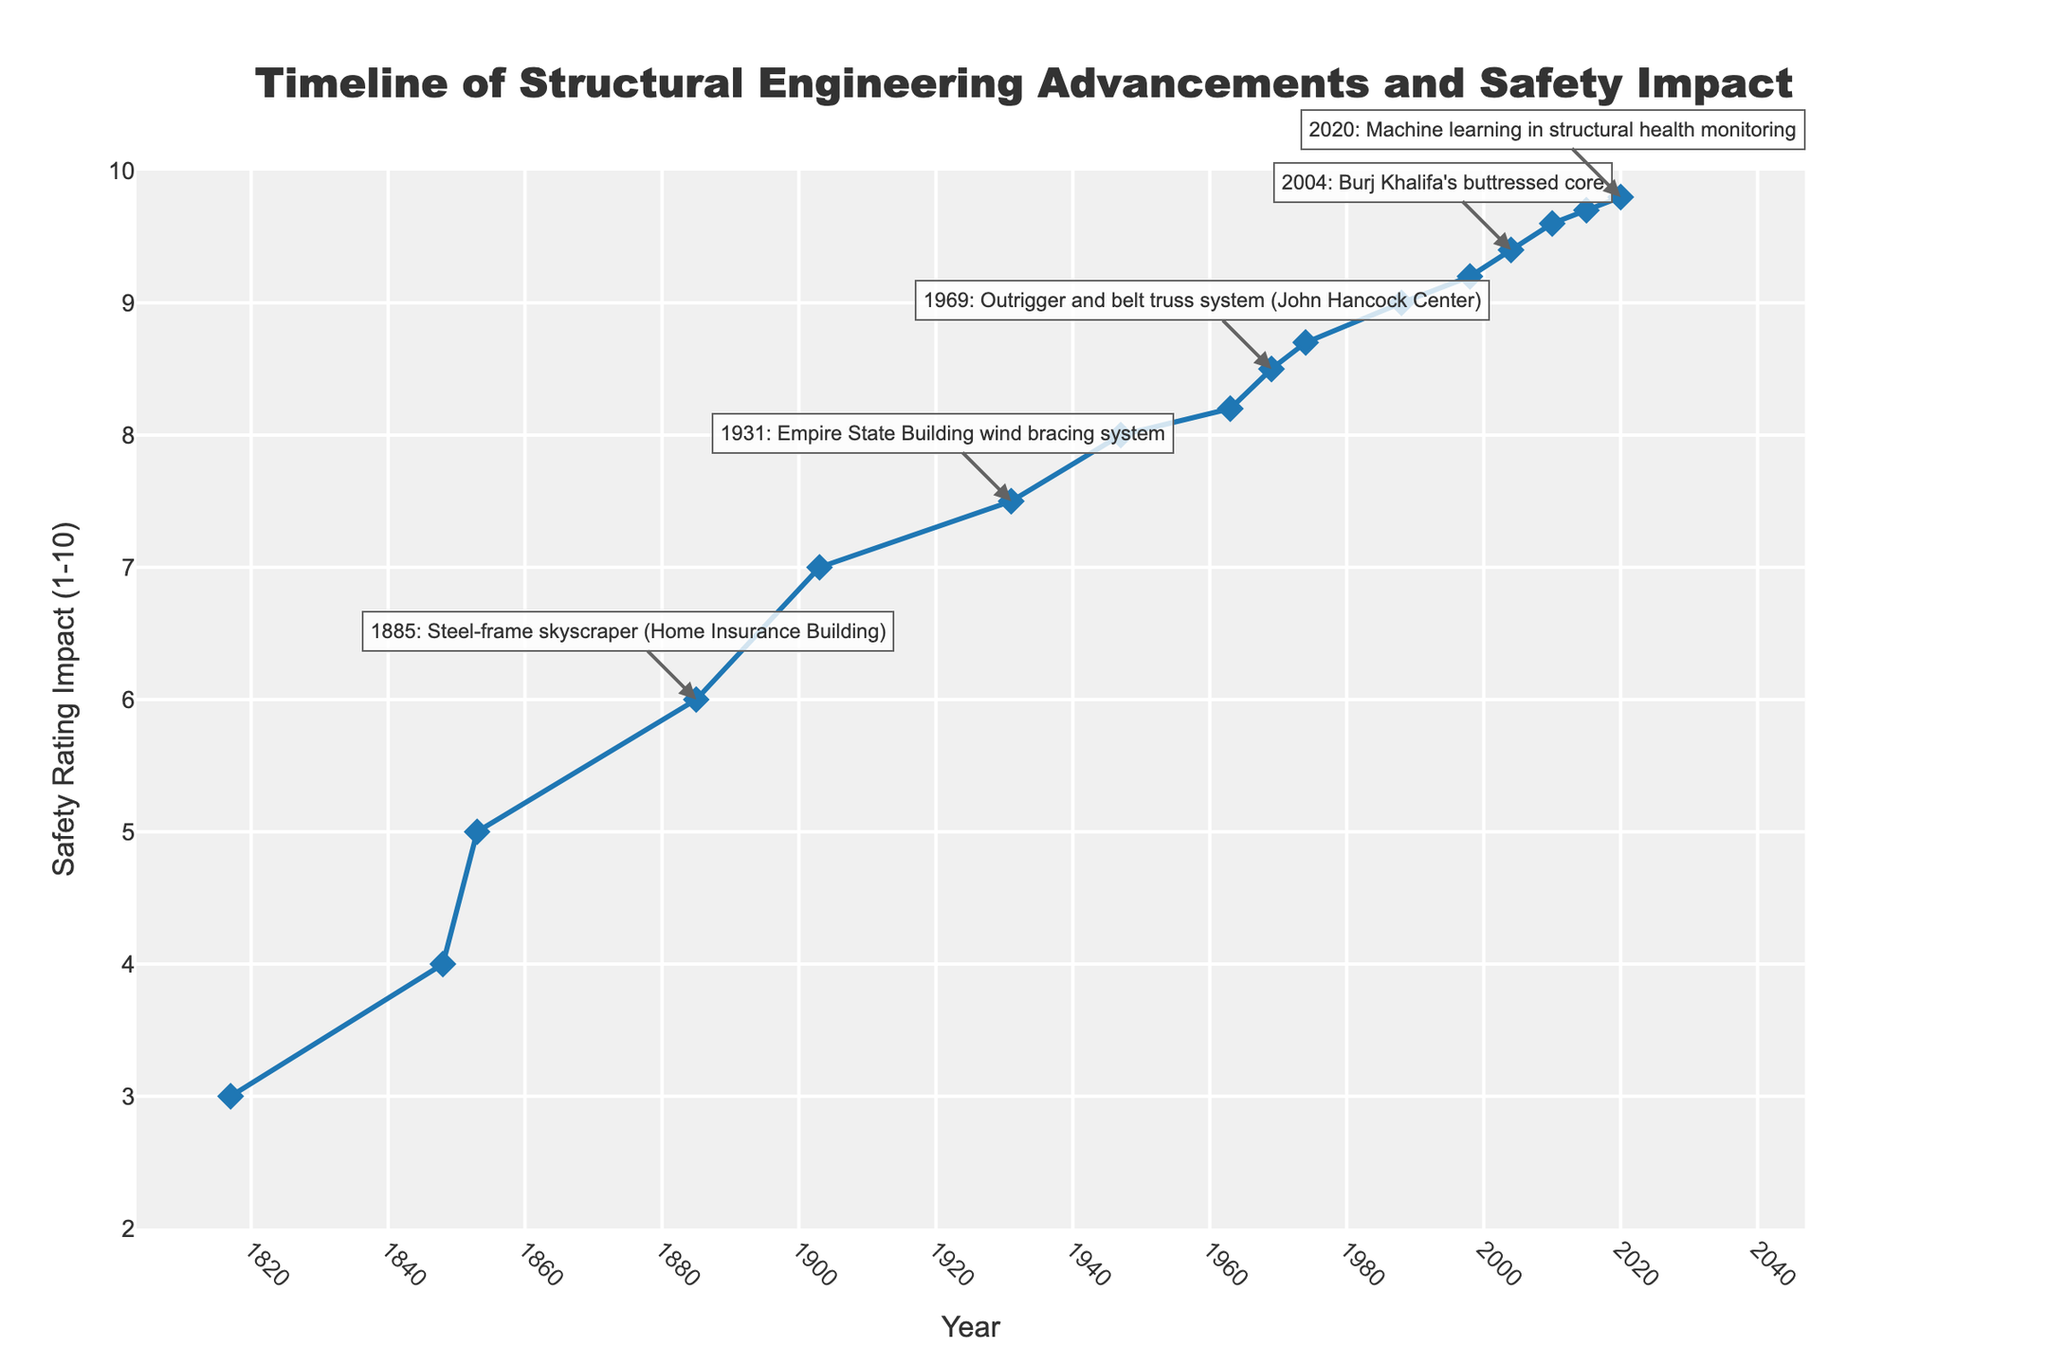Which advancement had the highest impact on building safety ratings, and what is the rating? Look at the plot to identify the point with the highest Safety Rating Impact value. The highest impact is in 2020 with Machine learning in structural health monitoring, which has a Safety Rating Impact of 9.8
Answer: Machine learning in structural health monitoring, 9.8 Between the years 1931 and 2004, which advancement improved building safety ratings the most? Compare the Safety Rating Impact values between 1931 and 2004. The advancement with the most significant improvement is the introduction of the buttressed core in 2004, with a Safety Rating Impact of 9.4
Answer: Buttressed core in 2004 What was the average Safety Rating Impact from 1800 to 1853? There are three advancements listed in this period (1817, 1848, 1853). Sum up their Safety Rating Impacts (3 + 4 + 5) = 12 and divide by 3 to get the average, which is 4
Answer: 4 How many advancements between 1900 and 2000 had a Safety Rating Impact of 8 or higher? Identifying such advancements requires counting the points where the Safety Rating Impact is 8 or higher in the specified years. Those advancements are: Prestressed concrete (1947), Tube structural system (1963), Outrigger and belt truss system (1969), and Tuned mass damper (1974)
Answer: 4 Which advancement from the 20th century had the lowest impact on building safety ratings, and what was the rating? Looking at the 20th century advancements, identify the one with the lowest Safety Rating Impact, which is the Empire State Building wind bracing system in 1931 with a Safety Rating Impact of 7.5
Answer: Empire State Building wind bracing system, 7.5 What is the difference in Safety Rating Impact between the I-beam development in 1848 and the diagrid structural system in 1998? Subtract the Safety Rating Impact of the I-beam development (4) from the diagrid structural system (9.2), resulting in 9.2 - 4 = 5.2
Answer: 5.2 What is the total number of advancements with a Safety Rating Impact greater than 8 from 1900 onwards? Count the advancements with a Safety Rating Impact greater than 8 from the year 1900 onwards: Prestressed concrete (8), Tube structural system (8.2), Outrigger and belt truss system (8.5), Tuned mass damper (8.7), Base isolation (9), Diagrid structural system (9.2), Buttressed core (9.4), Shanghai Tower's form (9.6), Advanced computational fluid dynamics (9.7), and Machine learning in structural health monitoring (9.8)
Answer: 10 What trend do you observe in Safety Rating Impact from 1800 to 2020? Observing the plot, the overall trend in Safety Rating Impact shows a steady increase, indicating continual improvements in building safety with each advancement
Answer: Steady increase Which advancement around the mid-20th century had a Safety Rating Impact greater than 8 and involved a new material? The plot shows that prestressed concrete in 1947 had a significant Safety Rating Impact of 8, and it introduced a new material for construction
Answer: Prestressed concrete in 1947 What is the Safety Rating Impact of all advancements combined between 1960 and 1970? Sum the Safety Rating Impacts of advancements within these years: Tube structural system (8.2 in 1963) and Outrigger and belt truss system (8.5 in 1969), resulting in 8.2 + 8.5 = 16.7
Answer: 16.7 